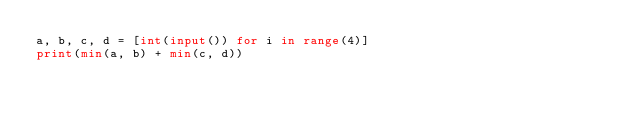Convert code to text. <code><loc_0><loc_0><loc_500><loc_500><_Python_>a, b, c, d = [int(input()) for i in range(4)]
print(min(a, b) + min(c, d))</code> 